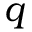Convert formula to latex. <formula><loc_0><loc_0><loc_500><loc_500>q</formula> 